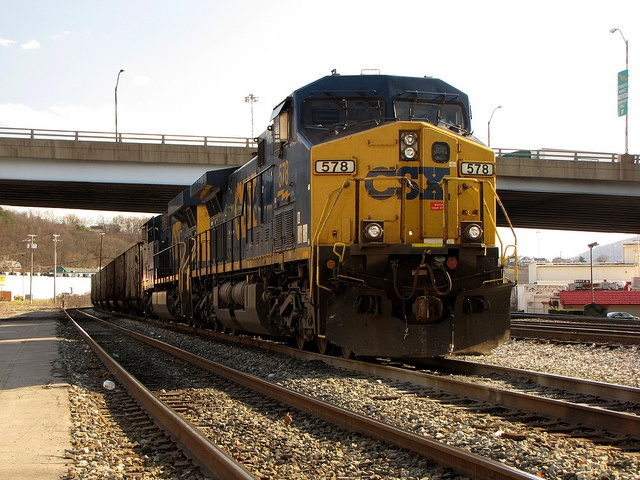Describe the objects in this image and their specific colors. I can see train in lightgray, black, olive, gray, and maroon tones and car in lightgray, gray, darkgray, and black tones in this image. 